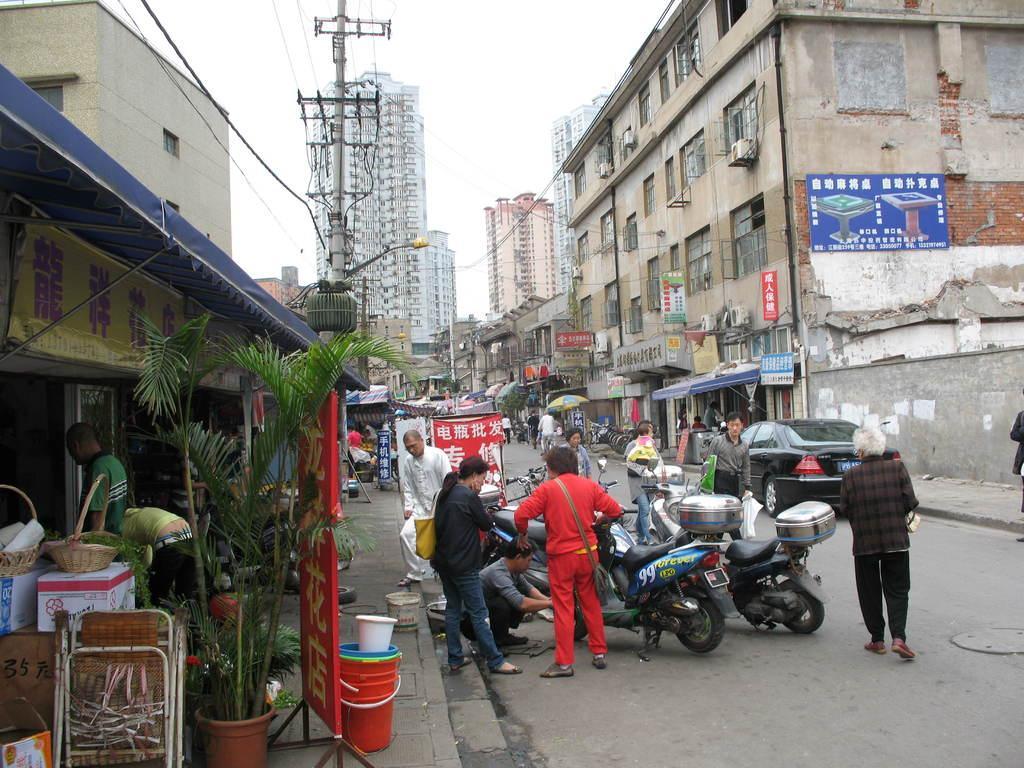Describe this image in one or two sentences. This is clicked in a street, there are few persons walking on the road with cars and motorcycles either side on it, on either side of the road there are buildings and store and above its sky. 